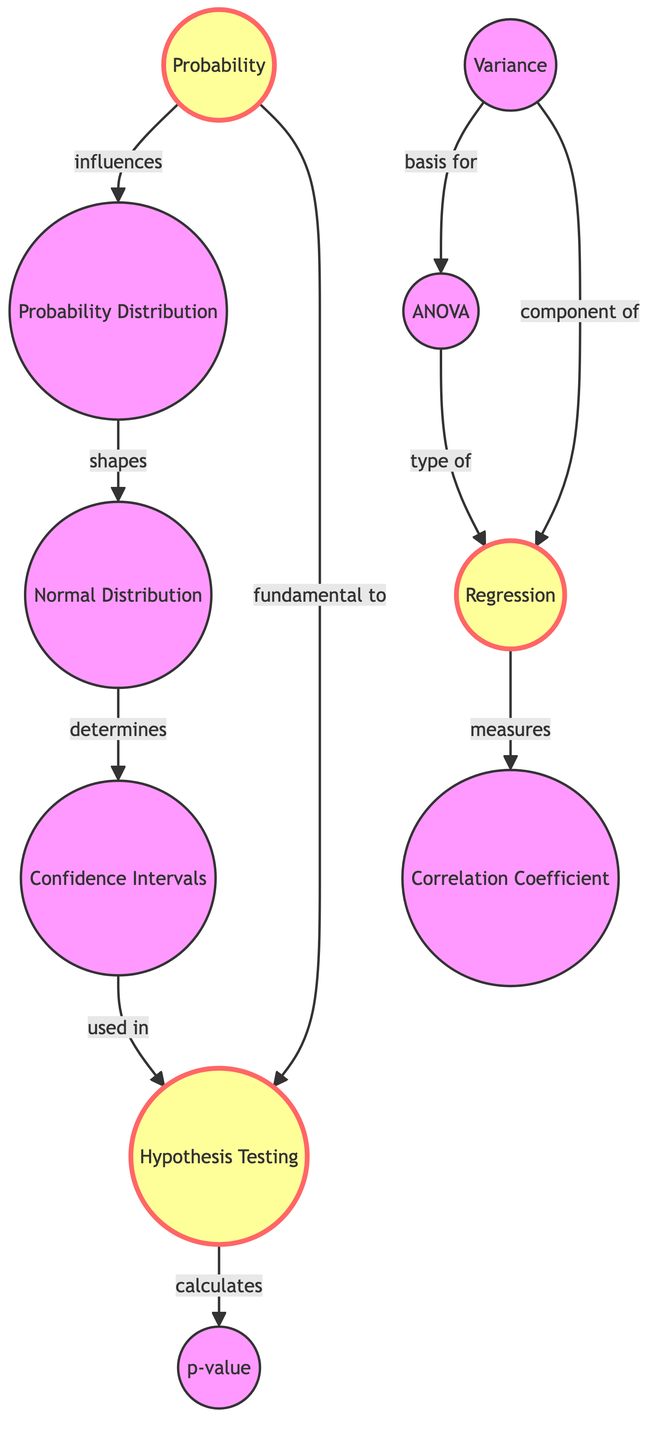What is the central concept of the diagram? The diagram focuses on the concept of Probability, which is indicated as a primary node influencing several other concepts such as Hypothesis Testing and Variance.
Answer: Probability How many nodes are in the diagram? Counting all distinct concepts listed in the data provides a total of ten nodes including Probability, Regression, and others.
Answer: Ten What relationship does Variance have with ANOVA? The diagram indicates that Variance serves as a basis for ANOVA, illustrating their interdependency in statistical analysis.
Answer: Basis for Which node is directly connected to Hypothesis Testing? The edge from Confidence Intervals indicates it is directly connected to Hypothesis Testing, which is used in statistical inference.
Answer: Confidence Intervals What does Regression measure, as represented in the diagram? The diagram shows that Regression measures the Correlation Coefficient, demonstrating the relationship between variables.
Answer: Correlation Coefficient If Variance influences ANOVA, what is the next concept it connects to? Following the diagram, after ANOVA, it connects to Regression, indicating that ANOVA leads into regression analysis.
Answer: Regression How do Probability Distributions relate to Normal Distribution? The edge indicates that Probability Distributions shape the Normal Distribution, showing how one concept develops into another.
Answer: Shapes Which statistical concept calculates the p-value? Hypothesis Testing calculates the p-value, as demonstrated in the direct influence depicted in the diagram.
Answer: Hypothesis Testing What is the influence of Probability on Hypothesis Testing? The diagram shows that Probability is fundamental to Hypothesis Testing, illustrating its essential role in the process.
Answer: Fundamental to 